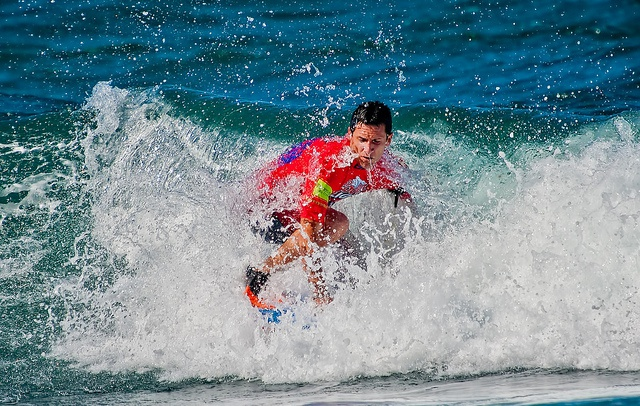Describe the objects in this image and their specific colors. I can see people in darkblue, darkgray, lightgray, lightpink, and brown tones and surfboard in darkblue, blue, red, lightgray, and gray tones in this image. 